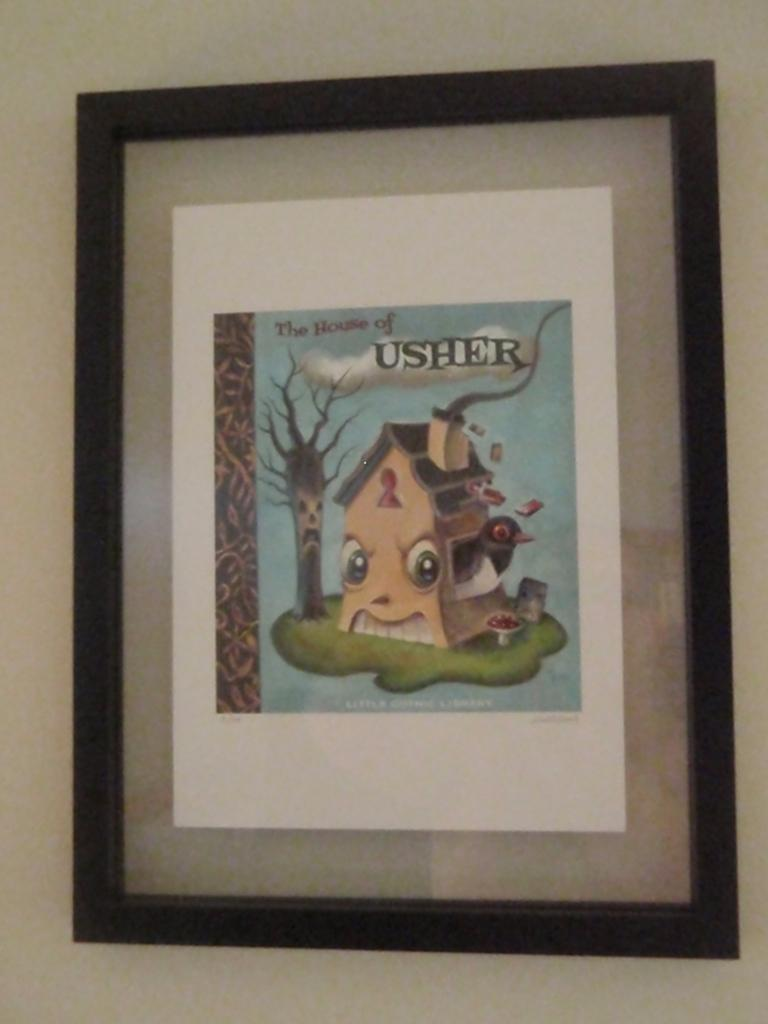What is the main object in the image? There is a drawing photo frame in the image. Where is the drawing photo frame located? The drawing photo frame is placed on a white wall. Is there a knife being used to cut the drawing photo frame in the image? No, there is no knife present in the image, and the drawing photo frame is not being cut. 